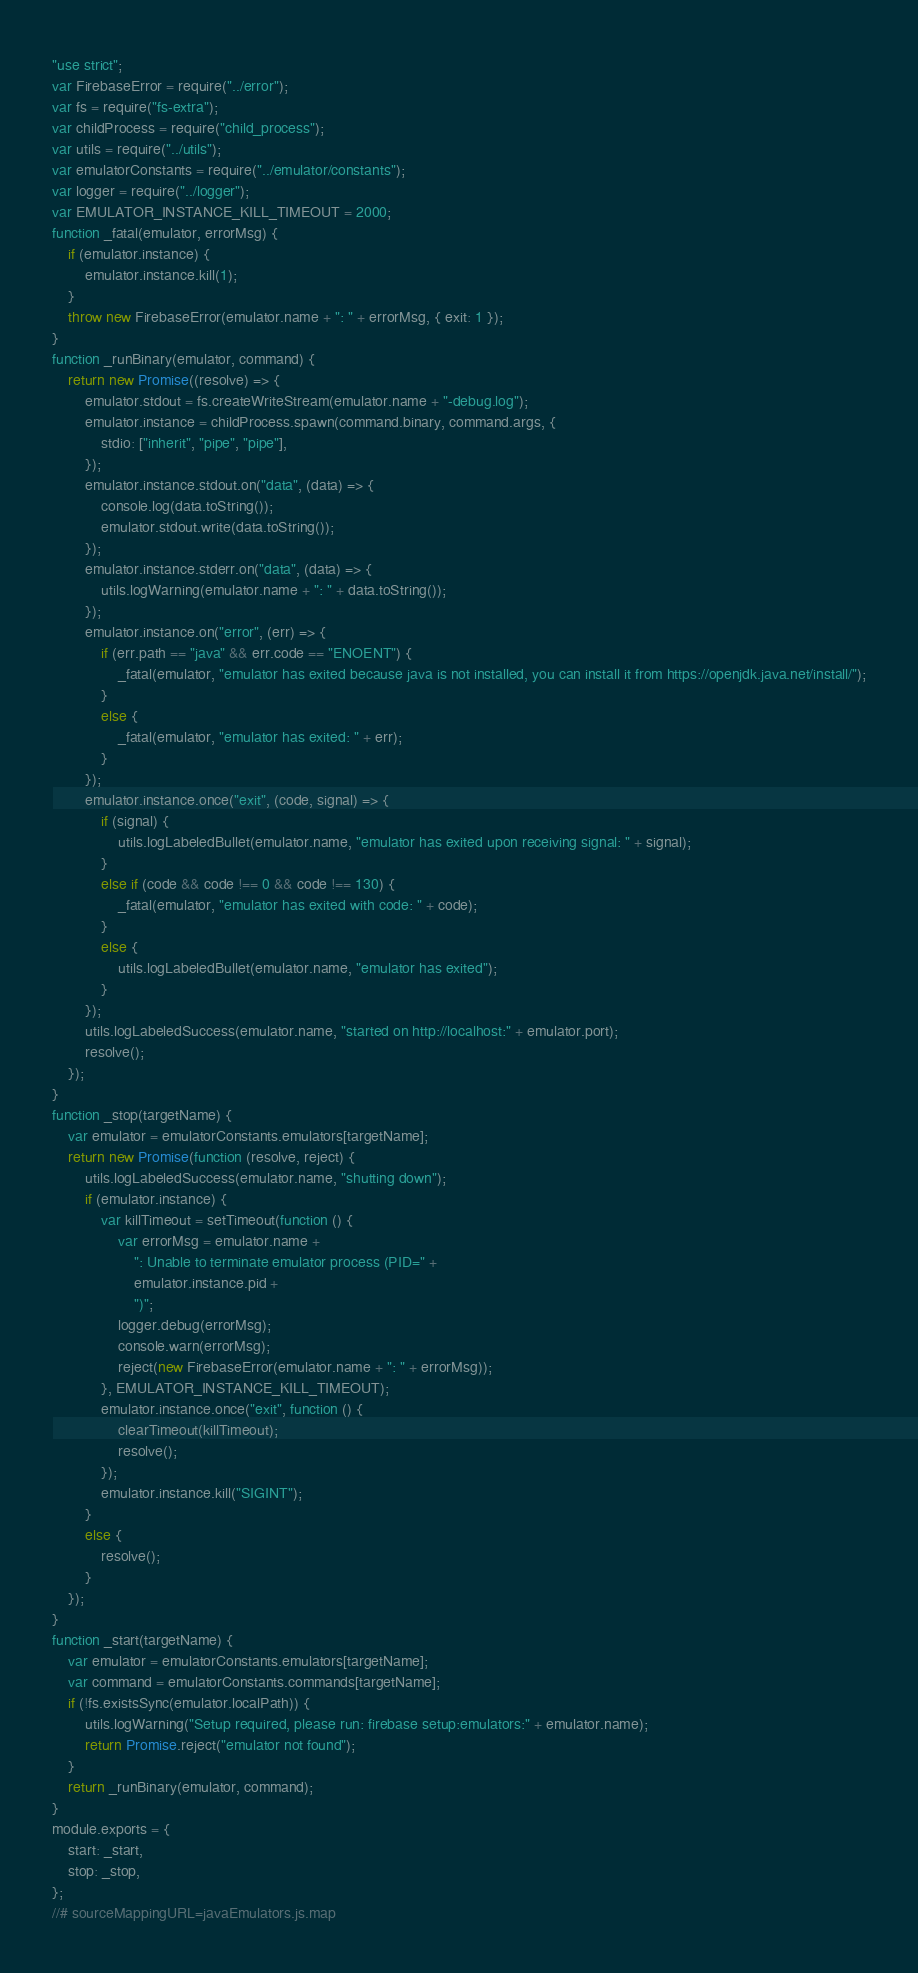Convert code to text. <code><loc_0><loc_0><loc_500><loc_500><_JavaScript_>"use strict";
var FirebaseError = require("../error");
var fs = require("fs-extra");
var childProcess = require("child_process");
var utils = require("../utils");
var emulatorConstants = require("../emulator/constants");
var logger = require("../logger");
var EMULATOR_INSTANCE_KILL_TIMEOUT = 2000;
function _fatal(emulator, errorMsg) {
    if (emulator.instance) {
        emulator.instance.kill(1);
    }
    throw new FirebaseError(emulator.name + ": " + errorMsg, { exit: 1 });
}
function _runBinary(emulator, command) {
    return new Promise((resolve) => {
        emulator.stdout = fs.createWriteStream(emulator.name + "-debug.log");
        emulator.instance = childProcess.spawn(command.binary, command.args, {
            stdio: ["inherit", "pipe", "pipe"],
        });
        emulator.instance.stdout.on("data", (data) => {
            console.log(data.toString());
            emulator.stdout.write(data.toString());
        });
        emulator.instance.stderr.on("data", (data) => {
            utils.logWarning(emulator.name + ": " + data.toString());
        });
        emulator.instance.on("error", (err) => {
            if (err.path == "java" && err.code == "ENOENT") {
                _fatal(emulator, "emulator has exited because java is not installed, you can install it from https://openjdk.java.net/install/");
            }
            else {
                _fatal(emulator, "emulator has exited: " + err);
            }
        });
        emulator.instance.once("exit", (code, signal) => {
            if (signal) {
                utils.logLabeledBullet(emulator.name, "emulator has exited upon receiving signal: " + signal);
            }
            else if (code && code !== 0 && code !== 130) {
                _fatal(emulator, "emulator has exited with code: " + code);
            }
            else {
                utils.logLabeledBullet(emulator.name, "emulator has exited");
            }
        });
        utils.logLabeledSuccess(emulator.name, "started on http://localhost:" + emulator.port);
        resolve();
    });
}
function _stop(targetName) {
    var emulator = emulatorConstants.emulators[targetName];
    return new Promise(function (resolve, reject) {
        utils.logLabeledSuccess(emulator.name, "shutting down");
        if (emulator.instance) {
            var killTimeout = setTimeout(function () {
                var errorMsg = emulator.name +
                    ": Unable to terminate emulator process (PID=" +
                    emulator.instance.pid +
                    ")";
                logger.debug(errorMsg);
                console.warn(errorMsg);
                reject(new FirebaseError(emulator.name + ": " + errorMsg));
            }, EMULATOR_INSTANCE_KILL_TIMEOUT);
            emulator.instance.once("exit", function () {
                clearTimeout(killTimeout);
                resolve();
            });
            emulator.instance.kill("SIGINT");
        }
        else {
            resolve();
        }
    });
}
function _start(targetName) {
    var emulator = emulatorConstants.emulators[targetName];
    var command = emulatorConstants.commands[targetName];
    if (!fs.existsSync(emulator.localPath)) {
        utils.logWarning("Setup required, please run: firebase setup:emulators:" + emulator.name);
        return Promise.reject("emulator not found");
    }
    return _runBinary(emulator, command);
}
module.exports = {
    start: _start,
    stop: _stop,
};
//# sourceMappingURL=javaEmulators.js.map</code> 